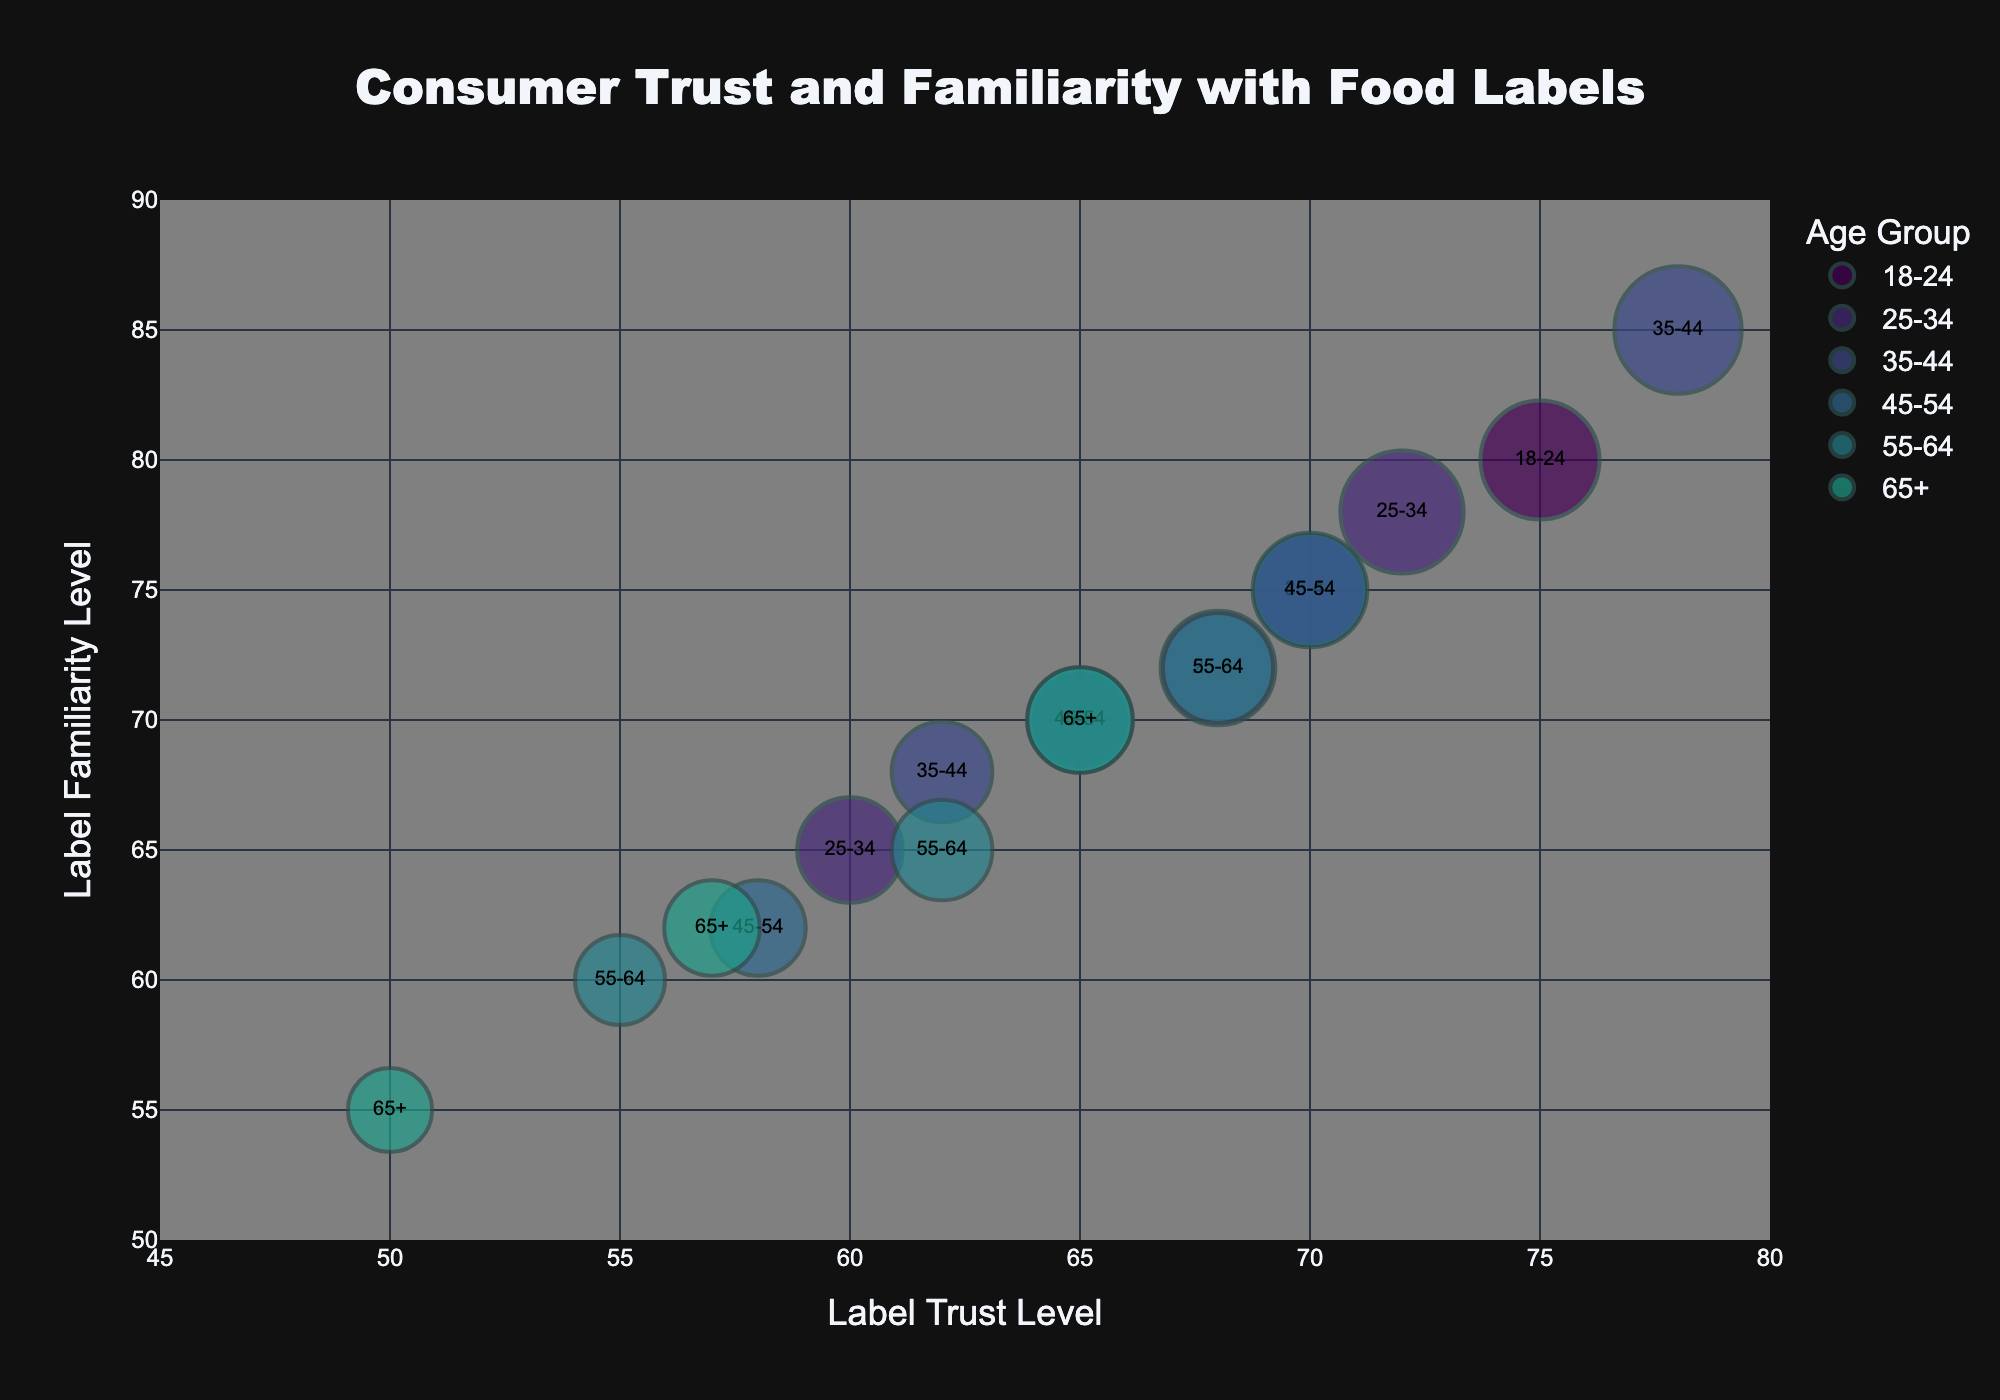What is the title of the chart? The title is usually found at the top of the chart. In this case, it reads "Consumer Trust and Familiarity with Food Labels".
Answer: Consumer Trust and Familiarity with Food Labels What are represented on the x and y axes? The x and y axes labels indicate what is being measured. Here, the x-axis represents "Label Trust Level" and the y-axis represents "Label Familiarity Level".
Answer: Label Trust Level (x-axis) and Label Familiarity Level (y-axis) What color scale is used to differentiate the demographic groups? The chart uses colors to represent different demographic groups. These colors are taken from the Viridis color scale, which typically ranges from dark purple to yellow.
Answer: Viridis color scale Which age group has the highest Label Trust Level? By observing the chart, the highest value along the x-axis (Label Trust Level) is associated with the "35-44" age group.
Answer: 35-44 What is the Label Trust Level for the 18-24 Age Group with High Income? Identify the bubble for the 18-24 Age Group with High Income and look at its x-axis value, which is 75.
Answer: 75 Among all the bubbles, which one represents the largest bubble size and to which demographic group does it belong? The largest bubble size is identified visually. The 35-44 Age Group with High Income is represented by the largest bubble.
Answer: 35-44 Age Group with High Income Which age group shows the lowest Label Familiarity Level? The lowest y-axis value, representing Label Familiarity Level, is associated with the age group "65+" with Low Income.
Answer: 65+ with Low Income How does the Label Trust Level compare between the 25-34 and 45-54 age groups with Medium Income? By comparing the x-axis values for Medium Income within both age groups, the 25-34 age group has a Label Trust Level of 68, while the 45-54 age group has 65.
Answer: The 25-34 age group has a higher Label Trust Level than the 45-54 age group What is the average Label Familiarity Level for the High-Income groups across all age groups? Calculate the average of the y-axis values for High-Income across all age groups: (80 + 78 + 85 + 75 + 72 + 70)/6. Thus, (80 + 78 + 85 + 75 + 72 + 70)/6 = 76.67.
Answer: 76.67 Which bubbles are closest to each other in terms of both Label Trust Level and Label Familiarity Level? Visually identify pairs of bubbles that are nearest to each other on the plot. The 18-24 Age Group with Medium Income and the 35-44 Age Group with Medium Income are closest to each other.
Answer: 18-24 Medium Income and 35-44 Medium Income 